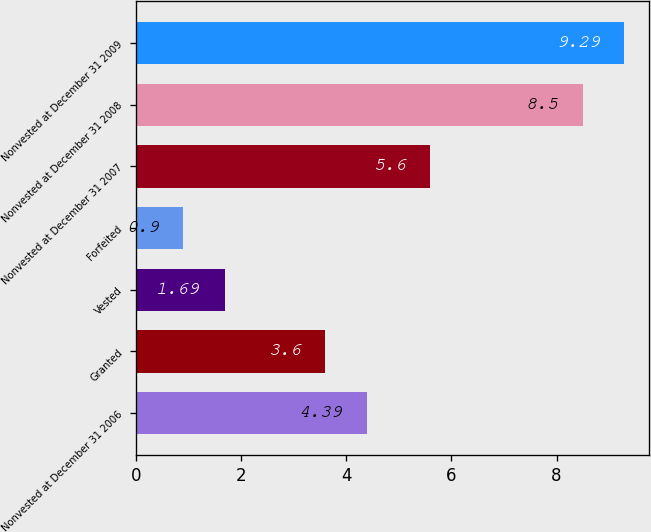Convert chart. <chart><loc_0><loc_0><loc_500><loc_500><bar_chart><fcel>Nonvested at December 31 2006<fcel>Granted<fcel>Vested<fcel>Forfeited<fcel>Nonvested at December 31 2007<fcel>Nonvested at December 31 2008<fcel>Nonvested at December 31 2009<nl><fcel>4.39<fcel>3.6<fcel>1.69<fcel>0.9<fcel>5.6<fcel>8.5<fcel>9.29<nl></chart> 